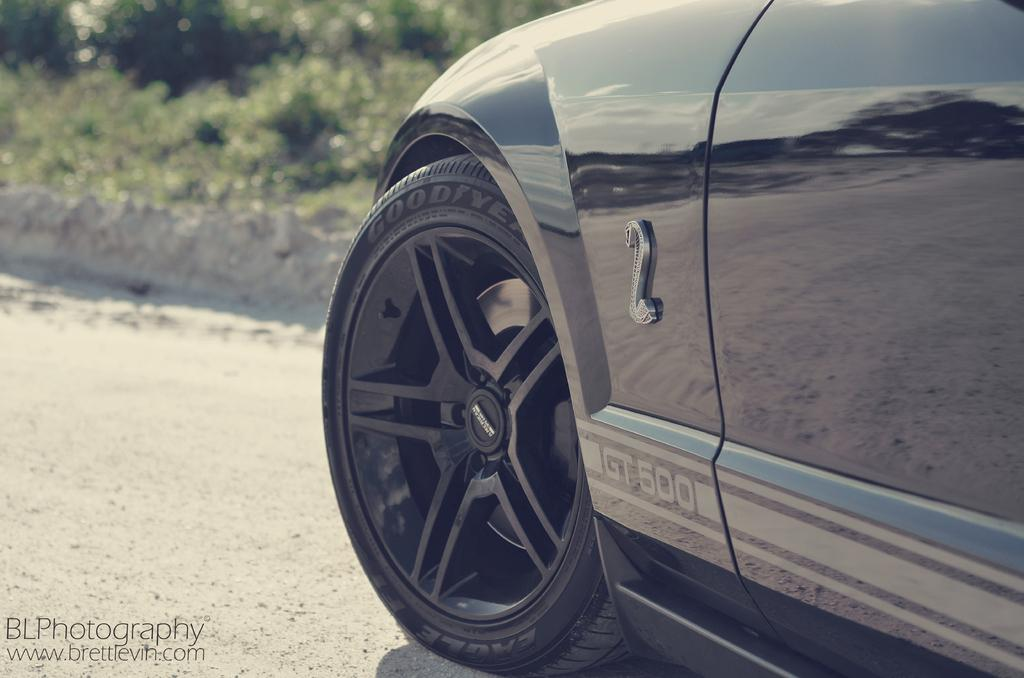What vehicle is located on the right side of the image? There is a car on the right side of the image. What type of natural elements can be seen in the background of the image? There are plants visible in the background of the image. Where is the text located in the image? The text is at the left bottom of the image. Can you tell me how many owls are sitting on the car in the image? There are no owls present in the image; it only features a car and plants in the background. 